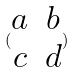Convert formula to latex. <formula><loc_0><loc_0><loc_500><loc_500>( \begin{matrix} a & b \\ c & d \end{matrix} )</formula> 